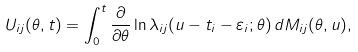<formula> <loc_0><loc_0><loc_500><loc_500>U _ { i j } ( \theta , t ) = \int _ { 0 } ^ { t } \frac { \partial } { \partial \theta } \ln \lambda _ { i j } ( u - t _ { i } - \varepsilon _ { i } ; \theta ) \, d M _ { i j } ( \theta , u ) ,</formula> 